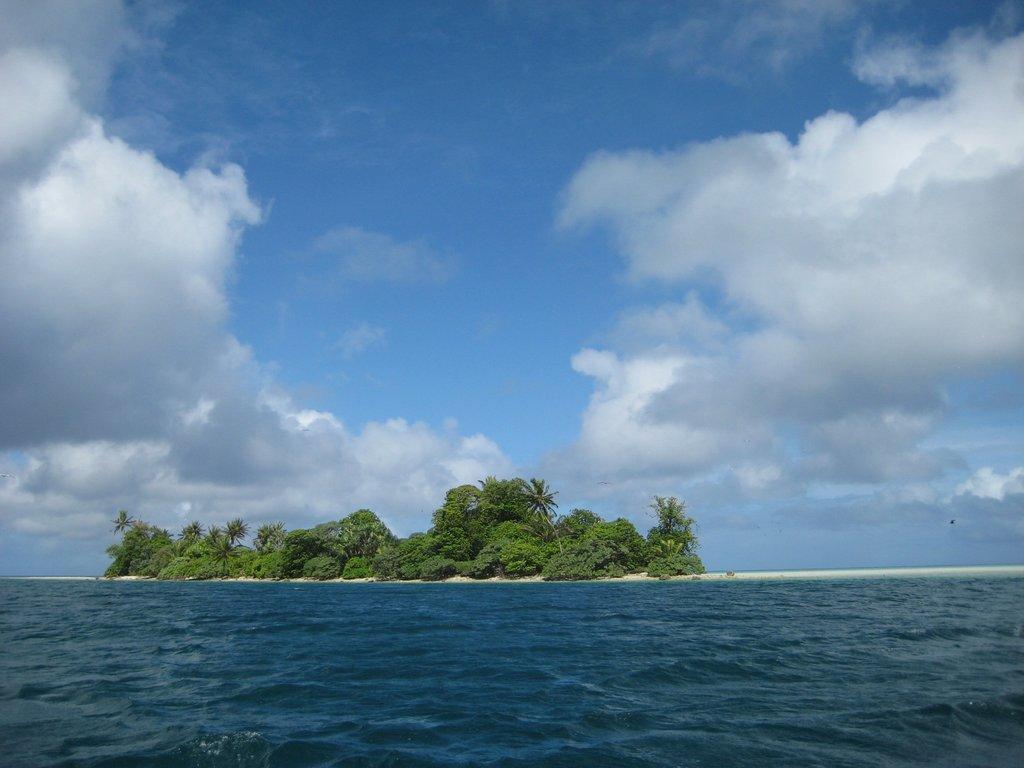Describe this image in one or two sentences. This is the picture of a sea. In this image there are trees on the island. At the top there is sky and there are clouds. At the bottom there is water. 